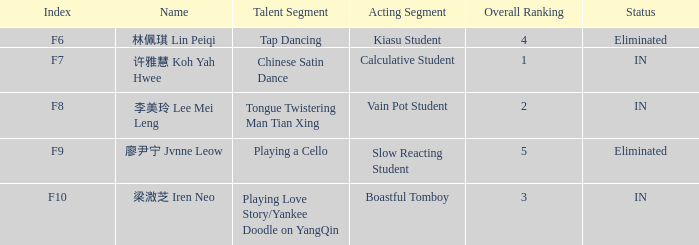Could you parse the entire table? {'header': ['Index', 'Name', 'Talent Segment', 'Acting Segment', 'Overall Ranking', 'Status'], 'rows': [['F6', '林佩琪 Lin Peiqi', 'Tap Dancing', 'Kiasu Student', '4', 'Eliminated'], ['F7', '许雅慧 Koh Yah Hwee', 'Chinese Satin Dance', 'Calculative Student', '1', 'IN'], ['F8', '李美玲 Lee Mei Leng', 'Tongue Twistering Man Tian Xing', 'Vain Pot Student', '2', 'IN'], ['F9', '廖尹宁 Jvnne Leow', 'Playing a Cello', 'Slow Reacting Student', '5', 'Eliminated'], ['F10', '梁溦芝 Iren Neo', 'Playing Love Story/Yankee Doodle on YangQin', 'Boastful Tomboy', '3', 'IN']]} For events having an f10 index, what is the combined total of their overall rankings? 3.0. 